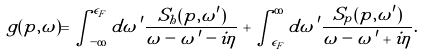Convert formula to latex. <formula><loc_0><loc_0><loc_500><loc_500>g ( p , \omega ) = \int _ { - \infty } ^ { \epsilon _ { F } } d \omega \, ^ { \prime } \frac { S _ { h } ( p , \omega ^ { \prime } ) } { \omega - \omega \, ^ { \prime } - i \eta } + \int _ { \epsilon _ { F } } ^ { \infty } d \omega \, ^ { \prime } \frac { S _ { p } ( p , \omega ^ { \prime } ) } { \omega - \omega \, ^ { \prime } + i \eta } .</formula> 